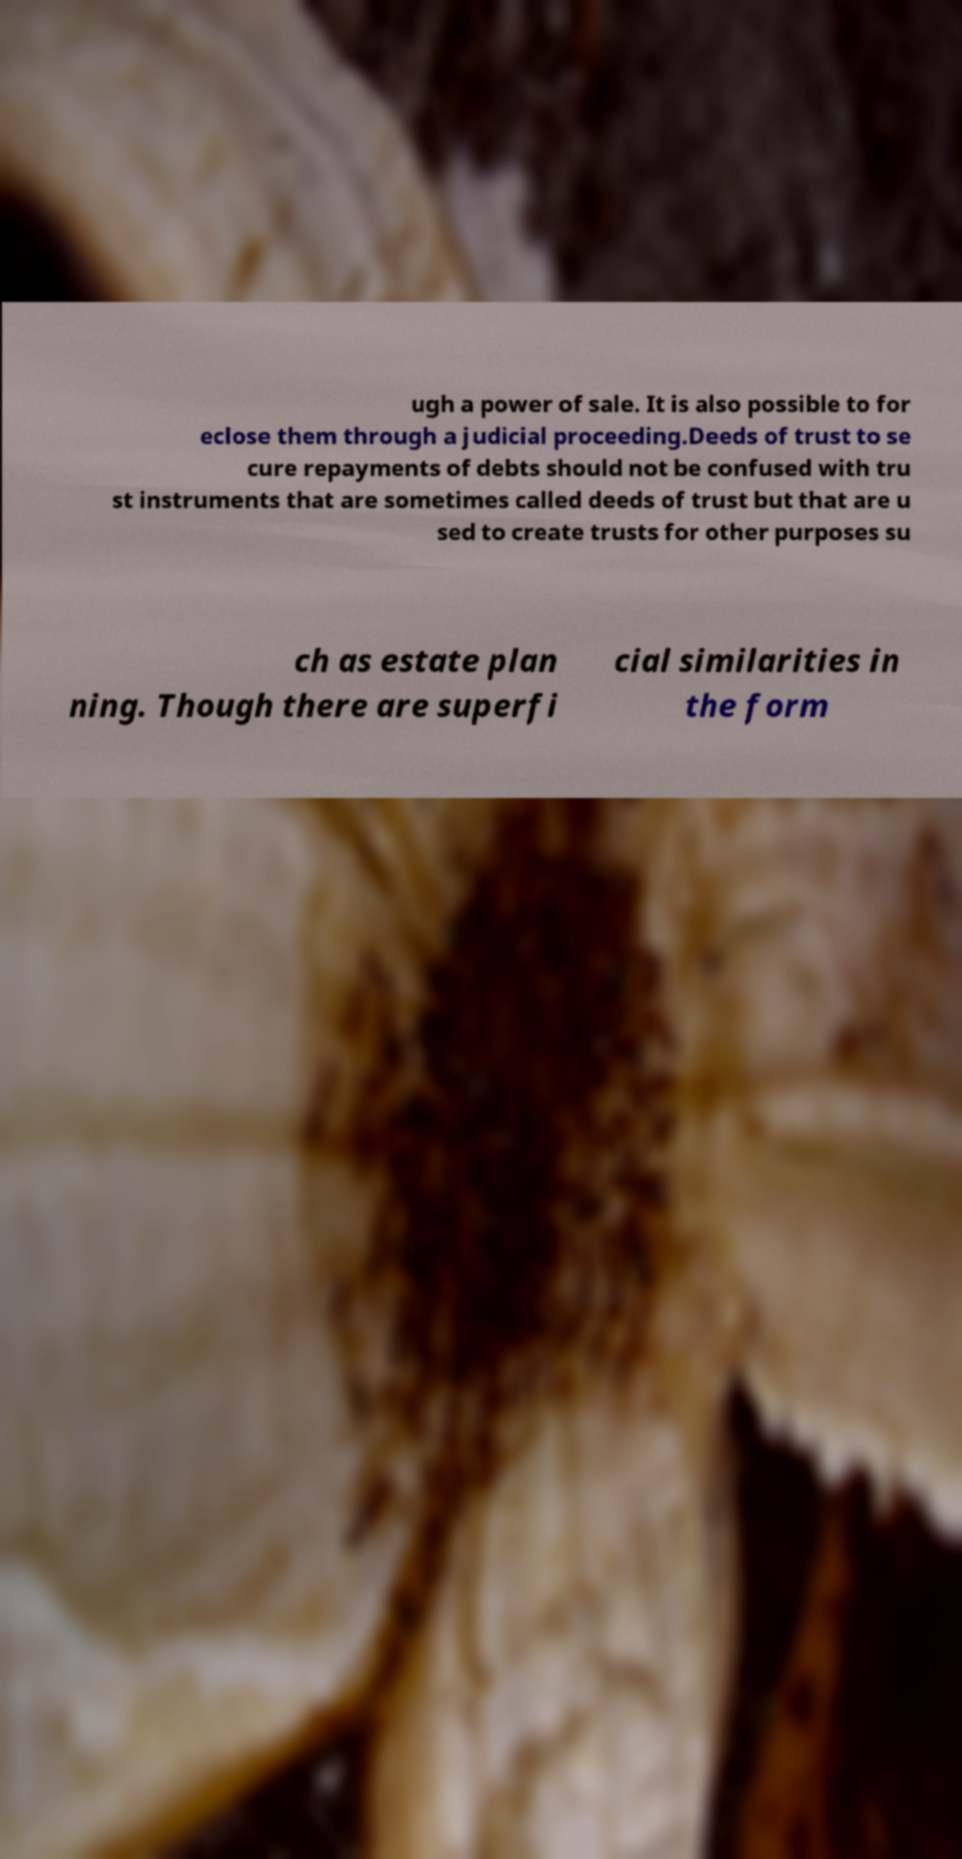For documentation purposes, I need the text within this image transcribed. Could you provide that? ugh a power of sale. It is also possible to for eclose them through a judicial proceeding.Deeds of trust to se cure repayments of debts should not be confused with tru st instruments that are sometimes called deeds of trust but that are u sed to create trusts for other purposes su ch as estate plan ning. Though there are superfi cial similarities in the form 